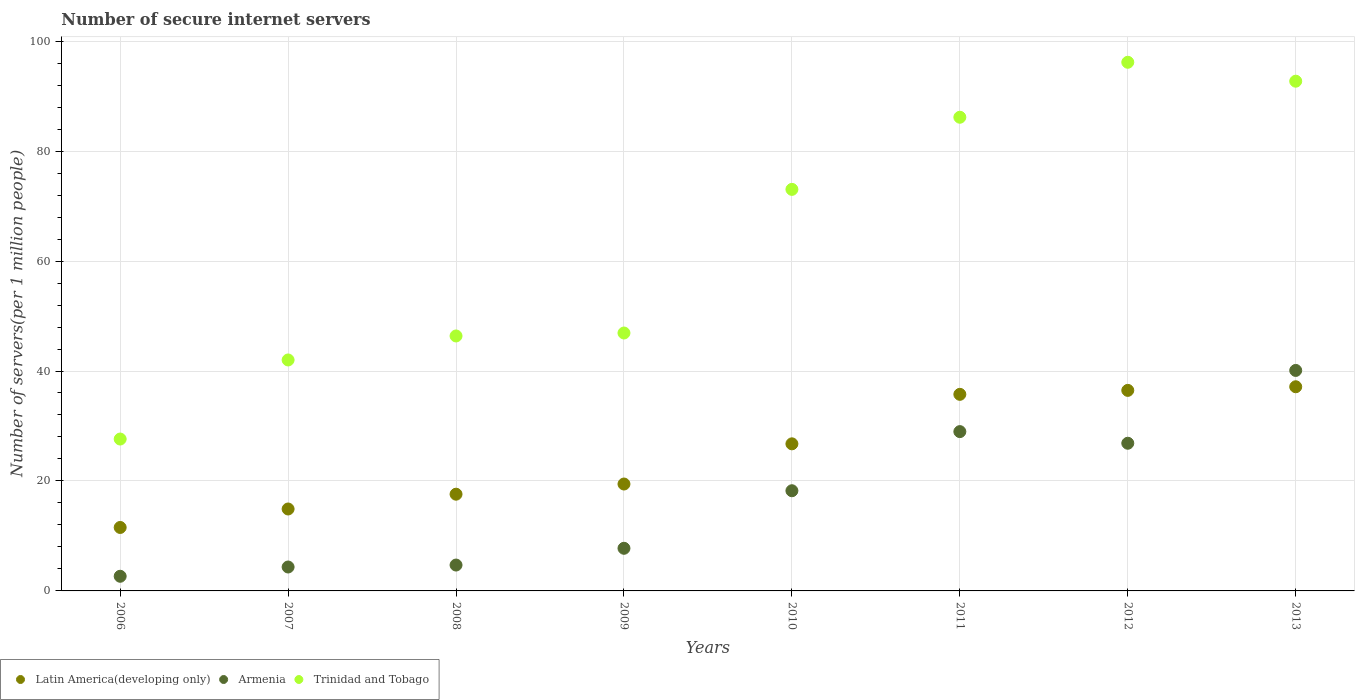What is the number of secure internet servers in Armenia in 2009?
Offer a very short reply. 7.75. Across all years, what is the maximum number of secure internet servers in Armenia?
Keep it short and to the point. 40.1. Across all years, what is the minimum number of secure internet servers in Trinidad and Tobago?
Provide a short and direct response. 27.63. In which year was the number of secure internet servers in Latin America(developing only) maximum?
Your answer should be very brief. 2013. What is the total number of secure internet servers in Armenia in the graph?
Provide a short and direct response. 133.64. What is the difference between the number of secure internet servers in Armenia in 2008 and that in 2009?
Provide a succinct answer. -3.05. What is the difference between the number of secure internet servers in Armenia in 2011 and the number of secure internet servers in Trinidad and Tobago in 2013?
Ensure brevity in your answer.  -63.74. What is the average number of secure internet servers in Trinidad and Tobago per year?
Ensure brevity in your answer.  63.87. In the year 2009, what is the difference between the number of secure internet servers in Latin America(developing only) and number of secure internet servers in Trinidad and Tobago?
Keep it short and to the point. -27.47. What is the ratio of the number of secure internet servers in Armenia in 2009 to that in 2010?
Offer a terse response. 0.43. Is the number of secure internet servers in Armenia in 2010 less than that in 2012?
Ensure brevity in your answer.  Yes. What is the difference between the highest and the second highest number of secure internet servers in Latin America(developing only)?
Your answer should be compact. 0.66. What is the difference between the highest and the lowest number of secure internet servers in Trinidad and Tobago?
Provide a short and direct response. 68.53. In how many years, is the number of secure internet servers in Trinidad and Tobago greater than the average number of secure internet servers in Trinidad and Tobago taken over all years?
Make the answer very short. 4. Does the number of secure internet servers in Trinidad and Tobago monotonically increase over the years?
Ensure brevity in your answer.  No. Is the number of secure internet servers in Trinidad and Tobago strictly greater than the number of secure internet servers in Latin America(developing only) over the years?
Your response must be concise. Yes. Is the number of secure internet servers in Armenia strictly less than the number of secure internet servers in Trinidad and Tobago over the years?
Ensure brevity in your answer.  Yes. What is the difference between two consecutive major ticks on the Y-axis?
Your answer should be compact. 20. Are the values on the major ticks of Y-axis written in scientific E-notation?
Offer a very short reply. No. Does the graph contain any zero values?
Your answer should be compact. No. Does the graph contain grids?
Give a very brief answer. Yes. What is the title of the graph?
Offer a very short reply. Number of secure internet servers. Does "Middle East & North Africa (all income levels)" appear as one of the legend labels in the graph?
Offer a terse response. No. What is the label or title of the Y-axis?
Provide a short and direct response. Number of servers(per 1 million people). What is the Number of servers(per 1 million people) of Latin America(developing only) in 2006?
Offer a terse response. 11.54. What is the Number of servers(per 1 million people) in Armenia in 2006?
Provide a short and direct response. 2.66. What is the Number of servers(per 1 million people) of Trinidad and Tobago in 2006?
Offer a very short reply. 27.63. What is the Number of servers(per 1 million people) of Latin America(developing only) in 2007?
Provide a succinct answer. 14.9. What is the Number of servers(per 1 million people) of Armenia in 2007?
Your answer should be very brief. 4.35. What is the Number of servers(per 1 million people) of Trinidad and Tobago in 2007?
Offer a very short reply. 42.01. What is the Number of servers(per 1 million people) of Latin America(developing only) in 2008?
Offer a very short reply. 17.59. What is the Number of servers(per 1 million people) in Armenia in 2008?
Your answer should be very brief. 4.71. What is the Number of servers(per 1 million people) of Trinidad and Tobago in 2008?
Your answer should be very brief. 46.37. What is the Number of servers(per 1 million people) in Latin America(developing only) in 2009?
Offer a terse response. 19.44. What is the Number of servers(per 1 million people) in Armenia in 2009?
Ensure brevity in your answer.  7.75. What is the Number of servers(per 1 million people) of Trinidad and Tobago in 2009?
Ensure brevity in your answer.  46.91. What is the Number of servers(per 1 million people) in Latin America(developing only) in 2010?
Provide a short and direct response. 26.75. What is the Number of servers(per 1 million people) of Armenia in 2010?
Offer a very short reply. 18.22. What is the Number of servers(per 1 million people) in Trinidad and Tobago in 2010?
Your response must be concise. 73.04. What is the Number of servers(per 1 million people) of Latin America(developing only) in 2011?
Provide a short and direct response. 35.76. What is the Number of servers(per 1 million people) of Armenia in 2011?
Your response must be concise. 28.98. What is the Number of servers(per 1 million people) of Trinidad and Tobago in 2011?
Your response must be concise. 86.16. What is the Number of servers(per 1 million people) of Latin America(developing only) in 2012?
Provide a short and direct response. 36.48. What is the Number of servers(per 1 million people) in Armenia in 2012?
Keep it short and to the point. 26.86. What is the Number of servers(per 1 million people) in Trinidad and Tobago in 2012?
Provide a succinct answer. 96.16. What is the Number of servers(per 1 million people) in Latin America(developing only) in 2013?
Ensure brevity in your answer.  37.14. What is the Number of servers(per 1 million people) of Armenia in 2013?
Your response must be concise. 40.1. What is the Number of servers(per 1 million people) in Trinidad and Tobago in 2013?
Keep it short and to the point. 92.71. Across all years, what is the maximum Number of servers(per 1 million people) in Latin America(developing only)?
Provide a short and direct response. 37.14. Across all years, what is the maximum Number of servers(per 1 million people) of Armenia?
Your response must be concise. 40.1. Across all years, what is the maximum Number of servers(per 1 million people) in Trinidad and Tobago?
Provide a short and direct response. 96.16. Across all years, what is the minimum Number of servers(per 1 million people) of Latin America(developing only)?
Provide a succinct answer. 11.54. Across all years, what is the minimum Number of servers(per 1 million people) in Armenia?
Your answer should be compact. 2.66. Across all years, what is the minimum Number of servers(per 1 million people) in Trinidad and Tobago?
Ensure brevity in your answer.  27.63. What is the total Number of servers(per 1 million people) in Latin America(developing only) in the graph?
Give a very brief answer. 199.61. What is the total Number of servers(per 1 million people) in Armenia in the graph?
Give a very brief answer. 133.64. What is the total Number of servers(per 1 million people) of Trinidad and Tobago in the graph?
Give a very brief answer. 510.98. What is the difference between the Number of servers(per 1 million people) of Latin America(developing only) in 2006 and that in 2007?
Ensure brevity in your answer.  -3.36. What is the difference between the Number of servers(per 1 million people) of Armenia in 2006 and that in 2007?
Offer a very short reply. -1.69. What is the difference between the Number of servers(per 1 million people) of Trinidad and Tobago in 2006 and that in 2007?
Make the answer very short. -14.38. What is the difference between the Number of servers(per 1 million people) of Latin America(developing only) in 2006 and that in 2008?
Offer a very short reply. -6.05. What is the difference between the Number of servers(per 1 million people) of Armenia in 2006 and that in 2008?
Your response must be concise. -2.04. What is the difference between the Number of servers(per 1 million people) of Trinidad and Tobago in 2006 and that in 2008?
Your answer should be compact. -18.75. What is the difference between the Number of servers(per 1 million people) in Latin America(developing only) in 2006 and that in 2009?
Provide a succinct answer. -7.9. What is the difference between the Number of servers(per 1 million people) of Armenia in 2006 and that in 2009?
Give a very brief answer. -5.09. What is the difference between the Number of servers(per 1 million people) of Trinidad and Tobago in 2006 and that in 2009?
Your answer should be very brief. -19.29. What is the difference between the Number of servers(per 1 million people) of Latin America(developing only) in 2006 and that in 2010?
Keep it short and to the point. -15.21. What is the difference between the Number of servers(per 1 million people) in Armenia in 2006 and that in 2010?
Offer a very short reply. -15.56. What is the difference between the Number of servers(per 1 million people) of Trinidad and Tobago in 2006 and that in 2010?
Make the answer very short. -45.41. What is the difference between the Number of servers(per 1 million people) in Latin America(developing only) in 2006 and that in 2011?
Your answer should be very brief. -24.21. What is the difference between the Number of servers(per 1 million people) in Armenia in 2006 and that in 2011?
Give a very brief answer. -26.31. What is the difference between the Number of servers(per 1 million people) in Trinidad and Tobago in 2006 and that in 2011?
Offer a very short reply. -58.53. What is the difference between the Number of servers(per 1 million people) in Latin America(developing only) in 2006 and that in 2012?
Keep it short and to the point. -24.93. What is the difference between the Number of servers(per 1 million people) of Armenia in 2006 and that in 2012?
Provide a short and direct response. -24.2. What is the difference between the Number of servers(per 1 million people) of Trinidad and Tobago in 2006 and that in 2012?
Your answer should be compact. -68.53. What is the difference between the Number of servers(per 1 million people) of Latin America(developing only) in 2006 and that in 2013?
Make the answer very short. -25.59. What is the difference between the Number of servers(per 1 million people) in Armenia in 2006 and that in 2013?
Offer a terse response. -37.44. What is the difference between the Number of servers(per 1 million people) in Trinidad and Tobago in 2006 and that in 2013?
Provide a short and direct response. -65.09. What is the difference between the Number of servers(per 1 million people) in Latin America(developing only) in 2007 and that in 2008?
Ensure brevity in your answer.  -2.69. What is the difference between the Number of servers(per 1 million people) in Armenia in 2007 and that in 2008?
Give a very brief answer. -0.36. What is the difference between the Number of servers(per 1 million people) in Trinidad and Tobago in 2007 and that in 2008?
Make the answer very short. -4.37. What is the difference between the Number of servers(per 1 million people) in Latin America(developing only) in 2007 and that in 2009?
Your answer should be very brief. -4.54. What is the difference between the Number of servers(per 1 million people) in Armenia in 2007 and that in 2009?
Your answer should be compact. -3.4. What is the difference between the Number of servers(per 1 million people) of Trinidad and Tobago in 2007 and that in 2009?
Make the answer very short. -4.9. What is the difference between the Number of servers(per 1 million people) of Latin America(developing only) in 2007 and that in 2010?
Ensure brevity in your answer.  -11.85. What is the difference between the Number of servers(per 1 million people) in Armenia in 2007 and that in 2010?
Your response must be concise. -13.87. What is the difference between the Number of servers(per 1 million people) of Trinidad and Tobago in 2007 and that in 2010?
Offer a terse response. -31.03. What is the difference between the Number of servers(per 1 million people) of Latin America(developing only) in 2007 and that in 2011?
Offer a very short reply. -20.85. What is the difference between the Number of servers(per 1 million people) of Armenia in 2007 and that in 2011?
Provide a succinct answer. -24.63. What is the difference between the Number of servers(per 1 million people) in Trinidad and Tobago in 2007 and that in 2011?
Your response must be concise. -44.15. What is the difference between the Number of servers(per 1 million people) of Latin America(developing only) in 2007 and that in 2012?
Keep it short and to the point. -21.57. What is the difference between the Number of servers(per 1 million people) of Armenia in 2007 and that in 2012?
Offer a very short reply. -22.51. What is the difference between the Number of servers(per 1 million people) in Trinidad and Tobago in 2007 and that in 2012?
Make the answer very short. -54.15. What is the difference between the Number of servers(per 1 million people) of Latin America(developing only) in 2007 and that in 2013?
Your response must be concise. -22.23. What is the difference between the Number of servers(per 1 million people) in Armenia in 2007 and that in 2013?
Provide a succinct answer. -35.75. What is the difference between the Number of servers(per 1 million people) in Trinidad and Tobago in 2007 and that in 2013?
Offer a terse response. -50.7. What is the difference between the Number of servers(per 1 million people) of Latin America(developing only) in 2008 and that in 2009?
Offer a terse response. -1.85. What is the difference between the Number of servers(per 1 million people) of Armenia in 2008 and that in 2009?
Provide a succinct answer. -3.05. What is the difference between the Number of servers(per 1 million people) in Trinidad and Tobago in 2008 and that in 2009?
Keep it short and to the point. -0.54. What is the difference between the Number of servers(per 1 million people) of Latin America(developing only) in 2008 and that in 2010?
Make the answer very short. -9.16. What is the difference between the Number of servers(per 1 million people) in Armenia in 2008 and that in 2010?
Make the answer very short. -13.52. What is the difference between the Number of servers(per 1 million people) in Trinidad and Tobago in 2008 and that in 2010?
Provide a short and direct response. -26.66. What is the difference between the Number of servers(per 1 million people) in Latin America(developing only) in 2008 and that in 2011?
Give a very brief answer. -18.16. What is the difference between the Number of servers(per 1 million people) of Armenia in 2008 and that in 2011?
Your response must be concise. -24.27. What is the difference between the Number of servers(per 1 million people) in Trinidad and Tobago in 2008 and that in 2011?
Offer a terse response. -39.78. What is the difference between the Number of servers(per 1 million people) of Latin America(developing only) in 2008 and that in 2012?
Provide a short and direct response. -18.88. What is the difference between the Number of servers(per 1 million people) of Armenia in 2008 and that in 2012?
Your response must be concise. -22.15. What is the difference between the Number of servers(per 1 million people) in Trinidad and Tobago in 2008 and that in 2012?
Your answer should be compact. -49.78. What is the difference between the Number of servers(per 1 million people) of Latin America(developing only) in 2008 and that in 2013?
Offer a very short reply. -19.54. What is the difference between the Number of servers(per 1 million people) of Armenia in 2008 and that in 2013?
Offer a terse response. -35.4. What is the difference between the Number of servers(per 1 million people) of Trinidad and Tobago in 2008 and that in 2013?
Make the answer very short. -46.34. What is the difference between the Number of servers(per 1 million people) of Latin America(developing only) in 2009 and that in 2010?
Provide a succinct answer. -7.31. What is the difference between the Number of servers(per 1 million people) of Armenia in 2009 and that in 2010?
Your answer should be very brief. -10.47. What is the difference between the Number of servers(per 1 million people) of Trinidad and Tobago in 2009 and that in 2010?
Your response must be concise. -26.12. What is the difference between the Number of servers(per 1 million people) of Latin America(developing only) in 2009 and that in 2011?
Keep it short and to the point. -16.31. What is the difference between the Number of servers(per 1 million people) of Armenia in 2009 and that in 2011?
Your answer should be compact. -21.22. What is the difference between the Number of servers(per 1 million people) of Trinidad and Tobago in 2009 and that in 2011?
Provide a succinct answer. -39.24. What is the difference between the Number of servers(per 1 million people) in Latin America(developing only) in 2009 and that in 2012?
Provide a succinct answer. -17.03. What is the difference between the Number of servers(per 1 million people) in Armenia in 2009 and that in 2012?
Your answer should be compact. -19.11. What is the difference between the Number of servers(per 1 million people) of Trinidad and Tobago in 2009 and that in 2012?
Keep it short and to the point. -49.24. What is the difference between the Number of servers(per 1 million people) in Latin America(developing only) in 2009 and that in 2013?
Keep it short and to the point. -17.69. What is the difference between the Number of servers(per 1 million people) in Armenia in 2009 and that in 2013?
Keep it short and to the point. -32.35. What is the difference between the Number of servers(per 1 million people) of Trinidad and Tobago in 2009 and that in 2013?
Provide a succinct answer. -45.8. What is the difference between the Number of servers(per 1 million people) in Latin America(developing only) in 2010 and that in 2011?
Ensure brevity in your answer.  -9. What is the difference between the Number of servers(per 1 million people) in Armenia in 2010 and that in 2011?
Your answer should be compact. -10.75. What is the difference between the Number of servers(per 1 million people) in Trinidad and Tobago in 2010 and that in 2011?
Provide a succinct answer. -13.12. What is the difference between the Number of servers(per 1 million people) in Latin America(developing only) in 2010 and that in 2012?
Provide a succinct answer. -9.72. What is the difference between the Number of servers(per 1 million people) in Armenia in 2010 and that in 2012?
Offer a very short reply. -8.64. What is the difference between the Number of servers(per 1 million people) in Trinidad and Tobago in 2010 and that in 2012?
Your response must be concise. -23.12. What is the difference between the Number of servers(per 1 million people) in Latin America(developing only) in 2010 and that in 2013?
Provide a succinct answer. -10.38. What is the difference between the Number of servers(per 1 million people) of Armenia in 2010 and that in 2013?
Offer a very short reply. -21.88. What is the difference between the Number of servers(per 1 million people) in Trinidad and Tobago in 2010 and that in 2013?
Your answer should be very brief. -19.68. What is the difference between the Number of servers(per 1 million people) in Latin America(developing only) in 2011 and that in 2012?
Give a very brief answer. -0.72. What is the difference between the Number of servers(per 1 million people) in Armenia in 2011 and that in 2012?
Your answer should be compact. 2.12. What is the difference between the Number of servers(per 1 million people) in Trinidad and Tobago in 2011 and that in 2012?
Offer a very short reply. -10. What is the difference between the Number of servers(per 1 million people) of Latin America(developing only) in 2011 and that in 2013?
Ensure brevity in your answer.  -1.38. What is the difference between the Number of servers(per 1 million people) in Armenia in 2011 and that in 2013?
Your answer should be very brief. -11.13. What is the difference between the Number of servers(per 1 million people) of Trinidad and Tobago in 2011 and that in 2013?
Your answer should be very brief. -6.56. What is the difference between the Number of servers(per 1 million people) in Latin America(developing only) in 2012 and that in 2013?
Provide a succinct answer. -0.66. What is the difference between the Number of servers(per 1 million people) of Armenia in 2012 and that in 2013?
Make the answer very short. -13.24. What is the difference between the Number of servers(per 1 million people) in Trinidad and Tobago in 2012 and that in 2013?
Give a very brief answer. 3.44. What is the difference between the Number of servers(per 1 million people) of Latin America(developing only) in 2006 and the Number of servers(per 1 million people) of Armenia in 2007?
Make the answer very short. 7.19. What is the difference between the Number of servers(per 1 million people) of Latin America(developing only) in 2006 and the Number of servers(per 1 million people) of Trinidad and Tobago in 2007?
Your response must be concise. -30.47. What is the difference between the Number of servers(per 1 million people) of Armenia in 2006 and the Number of servers(per 1 million people) of Trinidad and Tobago in 2007?
Your answer should be compact. -39.34. What is the difference between the Number of servers(per 1 million people) of Latin America(developing only) in 2006 and the Number of servers(per 1 million people) of Armenia in 2008?
Offer a very short reply. 6.84. What is the difference between the Number of servers(per 1 million people) of Latin America(developing only) in 2006 and the Number of servers(per 1 million people) of Trinidad and Tobago in 2008?
Offer a very short reply. -34.83. What is the difference between the Number of servers(per 1 million people) of Armenia in 2006 and the Number of servers(per 1 million people) of Trinidad and Tobago in 2008?
Your answer should be compact. -43.71. What is the difference between the Number of servers(per 1 million people) in Latin America(developing only) in 2006 and the Number of servers(per 1 million people) in Armenia in 2009?
Your response must be concise. 3.79. What is the difference between the Number of servers(per 1 million people) in Latin America(developing only) in 2006 and the Number of servers(per 1 million people) in Trinidad and Tobago in 2009?
Keep it short and to the point. -35.37. What is the difference between the Number of servers(per 1 million people) of Armenia in 2006 and the Number of servers(per 1 million people) of Trinidad and Tobago in 2009?
Your answer should be compact. -44.25. What is the difference between the Number of servers(per 1 million people) of Latin America(developing only) in 2006 and the Number of servers(per 1 million people) of Armenia in 2010?
Provide a succinct answer. -6.68. What is the difference between the Number of servers(per 1 million people) of Latin America(developing only) in 2006 and the Number of servers(per 1 million people) of Trinidad and Tobago in 2010?
Offer a terse response. -61.49. What is the difference between the Number of servers(per 1 million people) of Armenia in 2006 and the Number of servers(per 1 million people) of Trinidad and Tobago in 2010?
Give a very brief answer. -70.37. What is the difference between the Number of servers(per 1 million people) in Latin America(developing only) in 2006 and the Number of servers(per 1 million people) in Armenia in 2011?
Your answer should be compact. -17.43. What is the difference between the Number of servers(per 1 million people) of Latin America(developing only) in 2006 and the Number of servers(per 1 million people) of Trinidad and Tobago in 2011?
Provide a short and direct response. -74.61. What is the difference between the Number of servers(per 1 million people) in Armenia in 2006 and the Number of servers(per 1 million people) in Trinidad and Tobago in 2011?
Make the answer very short. -83.49. What is the difference between the Number of servers(per 1 million people) in Latin America(developing only) in 2006 and the Number of servers(per 1 million people) in Armenia in 2012?
Your response must be concise. -15.32. What is the difference between the Number of servers(per 1 million people) of Latin America(developing only) in 2006 and the Number of servers(per 1 million people) of Trinidad and Tobago in 2012?
Keep it short and to the point. -84.61. What is the difference between the Number of servers(per 1 million people) in Armenia in 2006 and the Number of servers(per 1 million people) in Trinidad and Tobago in 2012?
Provide a succinct answer. -93.49. What is the difference between the Number of servers(per 1 million people) in Latin America(developing only) in 2006 and the Number of servers(per 1 million people) in Armenia in 2013?
Your answer should be very brief. -28.56. What is the difference between the Number of servers(per 1 million people) of Latin America(developing only) in 2006 and the Number of servers(per 1 million people) of Trinidad and Tobago in 2013?
Offer a terse response. -81.17. What is the difference between the Number of servers(per 1 million people) of Armenia in 2006 and the Number of servers(per 1 million people) of Trinidad and Tobago in 2013?
Give a very brief answer. -90.05. What is the difference between the Number of servers(per 1 million people) of Latin America(developing only) in 2007 and the Number of servers(per 1 million people) of Armenia in 2008?
Offer a very short reply. 10.2. What is the difference between the Number of servers(per 1 million people) in Latin America(developing only) in 2007 and the Number of servers(per 1 million people) in Trinidad and Tobago in 2008?
Give a very brief answer. -31.47. What is the difference between the Number of servers(per 1 million people) of Armenia in 2007 and the Number of servers(per 1 million people) of Trinidad and Tobago in 2008?
Your answer should be compact. -42.02. What is the difference between the Number of servers(per 1 million people) of Latin America(developing only) in 2007 and the Number of servers(per 1 million people) of Armenia in 2009?
Ensure brevity in your answer.  7.15. What is the difference between the Number of servers(per 1 million people) of Latin America(developing only) in 2007 and the Number of servers(per 1 million people) of Trinidad and Tobago in 2009?
Your answer should be compact. -32.01. What is the difference between the Number of servers(per 1 million people) in Armenia in 2007 and the Number of servers(per 1 million people) in Trinidad and Tobago in 2009?
Your answer should be compact. -42.56. What is the difference between the Number of servers(per 1 million people) in Latin America(developing only) in 2007 and the Number of servers(per 1 million people) in Armenia in 2010?
Your answer should be very brief. -3.32. What is the difference between the Number of servers(per 1 million people) of Latin America(developing only) in 2007 and the Number of servers(per 1 million people) of Trinidad and Tobago in 2010?
Offer a very short reply. -58.13. What is the difference between the Number of servers(per 1 million people) in Armenia in 2007 and the Number of servers(per 1 million people) in Trinidad and Tobago in 2010?
Provide a succinct answer. -68.69. What is the difference between the Number of servers(per 1 million people) of Latin America(developing only) in 2007 and the Number of servers(per 1 million people) of Armenia in 2011?
Make the answer very short. -14.07. What is the difference between the Number of servers(per 1 million people) in Latin America(developing only) in 2007 and the Number of servers(per 1 million people) in Trinidad and Tobago in 2011?
Your answer should be compact. -71.25. What is the difference between the Number of servers(per 1 million people) in Armenia in 2007 and the Number of servers(per 1 million people) in Trinidad and Tobago in 2011?
Provide a succinct answer. -81.81. What is the difference between the Number of servers(per 1 million people) in Latin America(developing only) in 2007 and the Number of servers(per 1 million people) in Armenia in 2012?
Give a very brief answer. -11.96. What is the difference between the Number of servers(per 1 million people) of Latin America(developing only) in 2007 and the Number of servers(per 1 million people) of Trinidad and Tobago in 2012?
Your response must be concise. -81.25. What is the difference between the Number of servers(per 1 million people) of Armenia in 2007 and the Number of servers(per 1 million people) of Trinidad and Tobago in 2012?
Provide a short and direct response. -91.8. What is the difference between the Number of servers(per 1 million people) in Latin America(developing only) in 2007 and the Number of servers(per 1 million people) in Armenia in 2013?
Make the answer very short. -25.2. What is the difference between the Number of servers(per 1 million people) of Latin America(developing only) in 2007 and the Number of servers(per 1 million people) of Trinidad and Tobago in 2013?
Offer a very short reply. -77.81. What is the difference between the Number of servers(per 1 million people) of Armenia in 2007 and the Number of servers(per 1 million people) of Trinidad and Tobago in 2013?
Give a very brief answer. -88.36. What is the difference between the Number of servers(per 1 million people) of Latin America(developing only) in 2008 and the Number of servers(per 1 million people) of Armenia in 2009?
Provide a succinct answer. 9.84. What is the difference between the Number of servers(per 1 million people) of Latin America(developing only) in 2008 and the Number of servers(per 1 million people) of Trinidad and Tobago in 2009?
Ensure brevity in your answer.  -29.32. What is the difference between the Number of servers(per 1 million people) in Armenia in 2008 and the Number of servers(per 1 million people) in Trinidad and Tobago in 2009?
Keep it short and to the point. -42.21. What is the difference between the Number of servers(per 1 million people) in Latin America(developing only) in 2008 and the Number of servers(per 1 million people) in Armenia in 2010?
Offer a very short reply. -0.63. What is the difference between the Number of servers(per 1 million people) in Latin America(developing only) in 2008 and the Number of servers(per 1 million people) in Trinidad and Tobago in 2010?
Keep it short and to the point. -55.44. What is the difference between the Number of servers(per 1 million people) of Armenia in 2008 and the Number of servers(per 1 million people) of Trinidad and Tobago in 2010?
Offer a very short reply. -68.33. What is the difference between the Number of servers(per 1 million people) of Latin America(developing only) in 2008 and the Number of servers(per 1 million people) of Armenia in 2011?
Your answer should be very brief. -11.38. What is the difference between the Number of servers(per 1 million people) in Latin America(developing only) in 2008 and the Number of servers(per 1 million people) in Trinidad and Tobago in 2011?
Ensure brevity in your answer.  -68.56. What is the difference between the Number of servers(per 1 million people) of Armenia in 2008 and the Number of servers(per 1 million people) of Trinidad and Tobago in 2011?
Your answer should be very brief. -81.45. What is the difference between the Number of servers(per 1 million people) in Latin America(developing only) in 2008 and the Number of servers(per 1 million people) in Armenia in 2012?
Your answer should be compact. -9.27. What is the difference between the Number of servers(per 1 million people) of Latin America(developing only) in 2008 and the Number of servers(per 1 million people) of Trinidad and Tobago in 2012?
Make the answer very short. -78.56. What is the difference between the Number of servers(per 1 million people) in Armenia in 2008 and the Number of servers(per 1 million people) in Trinidad and Tobago in 2012?
Provide a short and direct response. -91.45. What is the difference between the Number of servers(per 1 million people) of Latin America(developing only) in 2008 and the Number of servers(per 1 million people) of Armenia in 2013?
Offer a terse response. -22.51. What is the difference between the Number of servers(per 1 million people) of Latin America(developing only) in 2008 and the Number of servers(per 1 million people) of Trinidad and Tobago in 2013?
Offer a very short reply. -75.12. What is the difference between the Number of servers(per 1 million people) of Armenia in 2008 and the Number of servers(per 1 million people) of Trinidad and Tobago in 2013?
Offer a terse response. -88.01. What is the difference between the Number of servers(per 1 million people) in Latin America(developing only) in 2009 and the Number of servers(per 1 million people) in Armenia in 2010?
Ensure brevity in your answer.  1.22. What is the difference between the Number of servers(per 1 million people) in Latin America(developing only) in 2009 and the Number of servers(per 1 million people) in Trinidad and Tobago in 2010?
Your response must be concise. -53.59. What is the difference between the Number of servers(per 1 million people) in Armenia in 2009 and the Number of servers(per 1 million people) in Trinidad and Tobago in 2010?
Provide a short and direct response. -65.28. What is the difference between the Number of servers(per 1 million people) of Latin America(developing only) in 2009 and the Number of servers(per 1 million people) of Armenia in 2011?
Provide a succinct answer. -9.53. What is the difference between the Number of servers(per 1 million people) of Latin America(developing only) in 2009 and the Number of servers(per 1 million people) of Trinidad and Tobago in 2011?
Offer a very short reply. -66.71. What is the difference between the Number of servers(per 1 million people) of Armenia in 2009 and the Number of servers(per 1 million people) of Trinidad and Tobago in 2011?
Ensure brevity in your answer.  -78.4. What is the difference between the Number of servers(per 1 million people) in Latin America(developing only) in 2009 and the Number of servers(per 1 million people) in Armenia in 2012?
Your answer should be compact. -7.42. What is the difference between the Number of servers(per 1 million people) in Latin America(developing only) in 2009 and the Number of servers(per 1 million people) in Trinidad and Tobago in 2012?
Make the answer very short. -76.71. What is the difference between the Number of servers(per 1 million people) of Armenia in 2009 and the Number of servers(per 1 million people) of Trinidad and Tobago in 2012?
Make the answer very short. -88.4. What is the difference between the Number of servers(per 1 million people) in Latin America(developing only) in 2009 and the Number of servers(per 1 million people) in Armenia in 2013?
Keep it short and to the point. -20.66. What is the difference between the Number of servers(per 1 million people) in Latin America(developing only) in 2009 and the Number of servers(per 1 million people) in Trinidad and Tobago in 2013?
Provide a short and direct response. -73.27. What is the difference between the Number of servers(per 1 million people) of Armenia in 2009 and the Number of servers(per 1 million people) of Trinidad and Tobago in 2013?
Offer a terse response. -84.96. What is the difference between the Number of servers(per 1 million people) in Latin America(developing only) in 2010 and the Number of servers(per 1 million people) in Armenia in 2011?
Your answer should be compact. -2.22. What is the difference between the Number of servers(per 1 million people) in Latin America(developing only) in 2010 and the Number of servers(per 1 million people) in Trinidad and Tobago in 2011?
Ensure brevity in your answer.  -59.4. What is the difference between the Number of servers(per 1 million people) of Armenia in 2010 and the Number of servers(per 1 million people) of Trinidad and Tobago in 2011?
Provide a succinct answer. -67.93. What is the difference between the Number of servers(per 1 million people) of Latin America(developing only) in 2010 and the Number of servers(per 1 million people) of Armenia in 2012?
Provide a short and direct response. -0.11. What is the difference between the Number of servers(per 1 million people) in Latin America(developing only) in 2010 and the Number of servers(per 1 million people) in Trinidad and Tobago in 2012?
Give a very brief answer. -69.4. What is the difference between the Number of servers(per 1 million people) of Armenia in 2010 and the Number of servers(per 1 million people) of Trinidad and Tobago in 2012?
Keep it short and to the point. -77.93. What is the difference between the Number of servers(per 1 million people) in Latin America(developing only) in 2010 and the Number of servers(per 1 million people) in Armenia in 2013?
Your answer should be very brief. -13.35. What is the difference between the Number of servers(per 1 million people) of Latin America(developing only) in 2010 and the Number of servers(per 1 million people) of Trinidad and Tobago in 2013?
Offer a terse response. -65.96. What is the difference between the Number of servers(per 1 million people) of Armenia in 2010 and the Number of servers(per 1 million people) of Trinidad and Tobago in 2013?
Provide a succinct answer. -74.49. What is the difference between the Number of servers(per 1 million people) of Latin America(developing only) in 2011 and the Number of servers(per 1 million people) of Armenia in 2012?
Keep it short and to the point. 8.9. What is the difference between the Number of servers(per 1 million people) of Latin America(developing only) in 2011 and the Number of servers(per 1 million people) of Trinidad and Tobago in 2012?
Ensure brevity in your answer.  -60.4. What is the difference between the Number of servers(per 1 million people) of Armenia in 2011 and the Number of servers(per 1 million people) of Trinidad and Tobago in 2012?
Your answer should be compact. -67.18. What is the difference between the Number of servers(per 1 million people) in Latin America(developing only) in 2011 and the Number of servers(per 1 million people) in Armenia in 2013?
Provide a short and direct response. -4.35. What is the difference between the Number of servers(per 1 million people) of Latin America(developing only) in 2011 and the Number of servers(per 1 million people) of Trinidad and Tobago in 2013?
Your answer should be very brief. -56.96. What is the difference between the Number of servers(per 1 million people) in Armenia in 2011 and the Number of servers(per 1 million people) in Trinidad and Tobago in 2013?
Ensure brevity in your answer.  -63.74. What is the difference between the Number of servers(per 1 million people) in Latin America(developing only) in 2012 and the Number of servers(per 1 million people) in Armenia in 2013?
Make the answer very short. -3.63. What is the difference between the Number of servers(per 1 million people) in Latin America(developing only) in 2012 and the Number of servers(per 1 million people) in Trinidad and Tobago in 2013?
Provide a succinct answer. -56.24. What is the difference between the Number of servers(per 1 million people) in Armenia in 2012 and the Number of servers(per 1 million people) in Trinidad and Tobago in 2013?
Your response must be concise. -65.85. What is the average Number of servers(per 1 million people) in Latin America(developing only) per year?
Offer a terse response. 24.95. What is the average Number of servers(per 1 million people) of Armenia per year?
Keep it short and to the point. 16.7. What is the average Number of servers(per 1 million people) in Trinidad and Tobago per year?
Provide a short and direct response. 63.87. In the year 2006, what is the difference between the Number of servers(per 1 million people) of Latin America(developing only) and Number of servers(per 1 million people) of Armenia?
Offer a very short reply. 8.88. In the year 2006, what is the difference between the Number of servers(per 1 million people) of Latin America(developing only) and Number of servers(per 1 million people) of Trinidad and Tobago?
Offer a terse response. -16.08. In the year 2006, what is the difference between the Number of servers(per 1 million people) of Armenia and Number of servers(per 1 million people) of Trinidad and Tobago?
Provide a succinct answer. -24.96. In the year 2007, what is the difference between the Number of servers(per 1 million people) in Latin America(developing only) and Number of servers(per 1 million people) in Armenia?
Ensure brevity in your answer.  10.55. In the year 2007, what is the difference between the Number of servers(per 1 million people) in Latin America(developing only) and Number of servers(per 1 million people) in Trinidad and Tobago?
Offer a terse response. -27.11. In the year 2007, what is the difference between the Number of servers(per 1 million people) of Armenia and Number of servers(per 1 million people) of Trinidad and Tobago?
Offer a very short reply. -37.66. In the year 2008, what is the difference between the Number of servers(per 1 million people) of Latin America(developing only) and Number of servers(per 1 million people) of Armenia?
Give a very brief answer. 12.89. In the year 2008, what is the difference between the Number of servers(per 1 million people) in Latin America(developing only) and Number of servers(per 1 million people) in Trinidad and Tobago?
Provide a short and direct response. -28.78. In the year 2008, what is the difference between the Number of servers(per 1 million people) of Armenia and Number of servers(per 1 million people) of Trinidad and Tobago?
Offer a very short reply. -41.67. In the year 2009, what is the difference between the Number of servers(per 1 million people) in Latin America(developing only) and Number of servers(per 1 million people) in Armenia?
Provide a short and direct response. 11.69. In the year 2009, what is the difference between the Number of servers(per 1 million people) in Latin America(developing only) and Number of servers(per 1 million people) in Trinidad and Tobago?
Provide a succinct answer. -27.47. In the year 2009, what is the difference between the Number of servers(per 1 million people) of Armenia and Number of servers(per 1 million people) of Trinidad and Tobago?
Ensure brevity in your answer.  -39.16. In the year 2010, what is the difference between the Number of servers(per 1 million people) of Latin America(developing only) and Number of servers(per 1 million people) of Armenia?
Offer a very short reply. 8.53. In the year 2010, what is the difference between the Number of servers(per 1 million people) of Latin America(developing only) and Number of servers(per 1 million people) of Trinidad and Tobago?
Ensure brevity in your answer.  -46.28. In the year 2010, what is the difference between the Number of servers(per 1 million people) in Armenia and Number of servers(per 1 million people) in Trinidad and Tobago?
Your answer should be compact. -54.82. In the year 2011, what is the difference between the Number of servers(per 1 million people) of Latin America(developing only) and Number of servers(per 1 million people) of Armenia?
Provide a succinct answer. 6.78. In the year 2011, what is the difference between the Number of servers(per 1 million people) in Latin America(developing only) and Number of servers(per 1 million people) in Trinidad and Tobago?
Offer a terse response. -50.4. In the year 2011, what is the difference between the Number of servers(per 1 million people) of Armenia and Number of servers(per 1 million people) of Trinidad and Tobago?
Provide a succinct answer. -57.18. In the year 2012, what is the difference between the Number of servers(per 1 million people) of Latin America(developing only) and Number of servers(per 1 million people) of Armenia?
Keep it short and to the point. 9.62. In the year 2012, what is the difference between the Number of servers(per 1 million people) in Latin America(developing only) and Number of servers(per 1 million people) in Trinidad and Tobago?
Give a very brief answer. -59.68. In the year 2012, what is the difference between the Number of servers(per 1 million people) of Armenia and Number of servers(per 1 million people) of Trinidad and Tobago?
Provide a succinct answer. -69.29. In the year 2013, what is the difference between the Number of servers(per 1 million people) in Latin America(developing only) and Number of servers(per 1 million people) in Armenia?
Ensure brevity in your answer.  -2.97. In the year 2013, what is the difference between the Number of servers(per 1 million people) of Latin America(developing only) and Number of servers(per 1 million people) of Trinidad and Tobago?
Your answer should be very brief. -55.58. In the year 2013, what is the difference between the Number of servers(per 1 million people) of Armenia and Number of servers(per 1 million people) of Trinidad and Tobago?
Your answer should be compact. -52.61. What is the ratio of the Number of servers(per 1 million people) in Latin America(developing only) in 2006 to that in 2007?
Offer a very short reply. 0.77. What is the ratio of the Number of servers(per 1 million people) of Armenia in 2006 to that in 2007?
Offer a very short reply. 0.61. What is the ratio of the Number of servers(per 1 million people) of Trinidad and Tobago in 2006 to that in 2007?
Your answer should be compact. 0.66. What is the ratio of the Number of servers(per 1 million people) of Latin America(developing only) in 2006 to that in 2008?
Keep it short and to the point. 0.66. What is the ratio of the Number of servers(per 1 million people) of Armenia in 2006 to that in 2008?
Provide a short and direct response. 0.57. What is the ratio of the Number of servers(per 1 million people) in Trinidad and Tobago in 2006 to that in 2008?
Provide a succinct answer. 0.6. What is the ratio of the Number of servers(per 1 million people) of Latin America(developing only) in 2006 to that in 2009?
Provide a short and direct response. 0.59. What is the ratio of the Number of servers(per 1 million people) in Armenia in 2006 to that in 2009?
Keep it short and to the point. 0.34. What is the ratio of the Number of servers(per 1 million people) of Trinidad and Tobago in 2006 to that in 2009?
Your response must be concise. 0.59. What is the ratio of the Number of servers(per 1 million people) in Latin America(developing only) in 2006 to that in 2010?
Provide a succinct answer. 0.43. What is the ratio of the Number of servers(per 1 million people) in Armenia in 2006 to that in 2010?
Offer a terse response. 0.15. What is the ratio of the Number of servers(per 1 million people) in Trinidad and Tobago in 2006 to that in 2010?
Provide a succinct answer. 0.38. What is the ratio of the Number of servers(per 1 million people) of Latin America(developing only) in 2006 to that in 2011?
Your answer should be compact. 0.32. What is the ratio of the Number of servers(per 1 million people) in Armenia in 2006 to that in 2011?
Your answer should be very brief. 0.09. What is the ratio of the Number of servers(per 1 million people) in Trinidad and Tobago in 2006 to that in 2011?
Provide a succinct answer. 0.32. What is the ratio of the Number of servers(per 1 million people) of Latin America(developing only) in 2006 to that in 2012?
Provide a succinct answer. 0.32. What is the ratio of the Number of servers(per 1 million people) in Armenia in 2006 to that in 2012?
Give a very brief answer. 0.1. What is the ratio of the Number of servers(per 1 million people) of Trinidad and Tobago in 2006 to that in 2012?
Keep it short and to the point. 0.29. What is the ratio of the Number of servers(per 1 million people) of Latin America(developing only) in 2006 to that in 2013?
Your response must be concise. 0.31. What is the ratio of the Number of servers(per 1 million people) in Armenia in 2006 to that in 2013?
Make the answer very short. 0.07. What is the ratio of the Number of servers(per 1 million people) in Trinidad and Tobago in 2006 to that in 2013?
Provide a short and direct response. 0.3. What is the ratio of the Number of servers(per 1 million people) in Latin America(developing only) in 2007 to that in 2008?
Offer a terse response. 0.85. What is the ratio of the Number of servers(per 1 million people) in Armenia in 2007 to that in 2008?
Make the answer very short. 0.92. What is the ratio of the Number of servers(per 1 million people) in Trinidad and Tobago in 2007 to that in 2008?
Give a very brief answer. 0.91. What is the ratio of the Number of servers(per 1 million people) in Latin America(developing only) in 2007 to that in 2009?
Make the answer very short. 0.77. What is the ratio of the Number of servers(per 1 million people) of Armenia in 2007 to that in 2009?
Offer a terse response. 0.56. What is the ratio of the Number of servers(per 1 million people) in Trinidad and Tobago in 2007 to that in 2009?
Your response must be concise. 0.9. What is the ratio of the Number of servers(per 1 million people) in Latin America(developing only) in 2007 to that in 2010?
Provide a succinct answer. 0.56. What is the ratio of the Number of servers(per 1 million people) in Armenia in 2007 to that in 2010?
Your answer should be very brief. 0.24. What is the ratio of the Number of servers(per 1 million people) of Trinidad and Tobago in 2007 to that in 2010?
Give a very brief answer. 0.58. What is the ratio of the Number of servers(per 1 million people) in Latin America(developing only) in 2007 to that in 2011?
Your response must be concise. 0.42. What is the ratio of the Number of servers(per 1 million people) in Armenia in 2007 to that in 2011?
Your answer should be compact. 0.15. What is the ratio of the Number of servers(per 1 million people) of Trinidad and Tobago in 2007 to that in 2011?
Ensure brevity in your answer.  0.49. What is the ratio of the Number of servers(per 1 million people) of Latin America(developing only) in 2007 to that in 2012?
Offer a very short reply. 0.41. What is the ratio of the Number of servers(per 1 million people) in Armenia in 2007 to that in 2012?
Your response must be concise. 0.16. What is the ratio of the Number of servers(per 1 million people) in Trinidad and Tobago in 2007 to that in 2012?
Provide a short and direct response. 0.44. What is the ratio of the Number of servers(per 1 million people) in Latin America(developing only) in 2007 to that in 2013?
Give a very brief answer. 0.4. What is the ratio of the Number of servers(per 1 million people) in Armenia in 2007 to that in 2013?
Keep it short and to the point. 0.11. What is the ratio of the Number of servers(per 1 million people) of Trinidad and Tobago in 2007 to that in 2013?
Your response must be concise. 0.45. What is the ratio of the Number of servers(per 1 million people) of Latin America(developing only) in 2008 to that in 2009?
Ensure brevity in your answer.  0.9. What is the ratio of the Number of servers(per 1 million people) of Armenia in 2008 to that in 2009?
Offer a very short reply. 0.61. What is the ratio of the Number of servers(per 1 million people) of Latin America(developing only) in 2008 to that in 2010?
Make the answer very short. 0.66. What is the ratio of the Number of servers(per 1 million people) of Armenia in 2008 to that in 2010?
Offer a terse response. 0.26. What is the ratio of the Number of servers(per 1 million people) in Trinidad and Tobago in 2008 to that in 2010?
Give a very brief answer. 0.63. What is the ratio of the Number of servers(per 1 million people) in Latin America(developing only) in 2008 to that in 2011?
Keep it short and to the point. 0.49. What is the ratio of the Number of servers(per 1 million people) of Armenia in 2008 to that in 2011?
Provide a short and direct response. 0.16. What is the ratio of the Number of servers(per 1 million people) in Trinidad and Tobago in 2008 to that in 2011?
Provide a short and direct response. 0.54. What is the ratio of the Number of servers(per 1 million people) in Latin America(developing only) in 2008 to that in 2012?
Offer a terse response. 0.48. What is the ratio of the Number of servers(per 1 million people) in Armenia in 2008 to that in 2012?
Keep it short and to the point. 0.18. What is the ratio of the Number of servers(per 1 million people) of Trinidad and Tobago in 2008 to that in 2012?
Your response must be concise. 0.48. What is the ratio of the Number of servers(per 1 million people) in Latin America(developing only) in 2008 to that in 2013?
Provide a short and direct response. 0.47. What is the ratio of the Number of servers(per 1 million people) in Armenia in 2008 to that in 2013?
Keep it short and to the point. 0.12. What is the ratio of the Number of servers(per 1 million people) in Trinidad and Tobago in 2008 to that in 2013?
Offer a terse response. 0.5. What is the ratio of the Number of servers(per 1 million people) of Latin America(developing only) in 2009 to that in 2010?
Your response must be concise. 0.73. What is the ratio of the Number of servers(per 1 million people) in Armenia in 2009 to that in 2010?
Your answer should be compact. 0.43. What is the ratio of the Number of servers(per 1 million people) of Trinidad and Tobago in 2009 to that in 2010?
Keep it short and to the point. 0.64. What is the ratio of the Number of servers(per 1 million people) of Latin America(developing only) in 2009 to that in 2011?
Offer a terse response. 0.54. What is the ratio of the Number of servers(per 1 million people) of Armenia in 2009 to that in 2011?
Your response must be concise. 0.27. What is the ratio of the Number of servers(per 1 million people) in Trinidad and Tobago in 2009 to that in 2011?
Keep it short and to the point. 0.54. What is the ratio of the Number of servers(per 1 million people) of Latin America(developing only) in 2009 to that in 2012?
Offer a terse response. 0.53. What is the ratio of the Number of servers(per 1 million people) in Armenia in 2009 to that in 2012?
Your answer should be very brief. 0.29. What is the ratio of the Number of servers(per 1 million people) in Trinidad and Tobago in 2009 to that in 2012?
Your response must be concise. 0.49. What is the ratio of the Number of servers(per 1 million people) of Latin America(developing only) in 2009 to that in 2013?
Give a very brief answer. 0.52. What is the ratio of the Number of servers(per 1 million people) in Armenia in 2009 to that in 2013?
Your answer should be very brief. 0.19. What is the ratio of the Number of servers(per 1 million people) of Trinidad and Tobago in 2009 to that in 2013?
Your response must be concise. 0.51. What is the ratio of the Number of servers(per 1 million people) in Latin America(developing only) in 2010 to that in 2011?
Provide a succinct answer. 0.75. What is the ratio of the Number of servers(per 1 million people) of Armenia in 2010 to that in 2011?
Your response must be concise. 0.63. What is the ratio of the Number of servers(per 1 million people) of Trinidad and Tobago in 2010 to that in 2011?
Offer a terse response. 0.85. What is the ratio of the Number of servers(per 1 million people) of Latin America(developing only) in 2010 to that in 2012?
Offer a very short reply. 0.73. What is the ratio of the Number of servers(per 1 million people) of Armenia in 2010 to that in 2012?
Keep it short and to the point. 0.68. What is the ratio of the Number of servers(per 1 million people) of Trinidad and Tobago in 2010 to that in 2012?
Your answer should be compact. 0.76. What is the ratio of the Number of servers(per 1 million people) in Latin America(developing only) in 2010 to that in 2013?
Provide a succinct answer. 0.72. What is the ratio of the Number of servers(per 1 million people) of Armenia in 2010 to that in 2013?
Make the answer very short. 0.45. What is the ratio of the Number of servers(per 1 million people) of Trinidad and Tobago in 2010 to that in 2013?
Your response must be concise. 0.79. What is the ratio of the Number of servers(per 1 million people) in Latin America(developing only) in 2011 to that in 2012?
Offer a very short reply. 0.98. What is the ratio of the Number of servers(per 1 million people) in Armenia in 2011 to that in 2012?
Your response must be concise. 1.08. What is the ratio of the Number of servers(per 1 million people) of Trinidad and Tobago in 2011 to that in 2012?
Your response must be concise. 0.9. What is the ratio of the Number of servers(per 1 million people) in Latin America(developing only) in 2011 to that in 2013?
Give a very brief answer. 0.96. What is the ratio of the Number of servers(per 1 million people) in Armenia in 2011 to that in 2013?
Offer a very short reply. 0.72. What is the ratio of the Number of servers(per 1 million people) in Trinidad and Tobago in 2011 to that in 2013?
Give a very brief answer. 0.93. What is the ratio of the Number of servers(per 1 million people) in Latin America(developing only) in 2012 to that in 2013?
Give a very brief answer. 0.98. What is the ratio of the Number of servers(per 1 million people) in Armenia in 2012 to that in 2013?
Make the answer very short. 0.67. What is the ratio of the Number of servers(per 1 million people) in Trinidad and Tobago in 2012 to that in 2013?
Offer a terse response. 1.04. What is the difference between the highest and the second highest Number of servers(per 1 million people) of Latin America(developing only)?
Your response must be concise. 0.66. What is the difference between the highest and the second highest Number of servers(per 1 million people) in Armenia?
Ensure brevity in your answer.  11.13. What is the difference between the highest and the second highest Number of servers(per 1 million people) in Trinidad and Tobago?
Make the answer very short. 3.44. What is the difference between the highest and the lowest Number of servers(per 1 million people) in Latin America(developing only)?
Give a very brief answer. 25.59. What is the difference between the highest and the lowest Number of servers(per 1 million people) of Armenia?
Your answer should be very brief. 37.44. What is the difference between the highest and the lowest Number of servers(per 1 million people) in Trinidad and Tobago?
Your answer should be very brief. 68.53. 